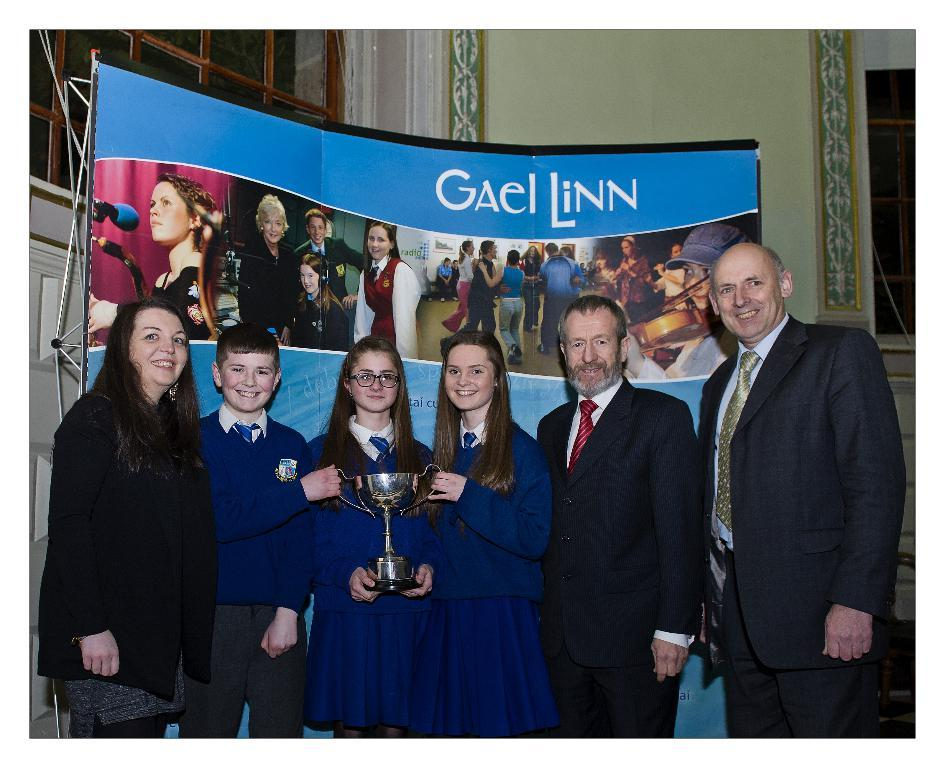What is happening in the image? There are people standing in the image, some of whom are students. What are the students holding in the image? The students are holding a trophy. What can be seen in the background of the image? There is a window and a wall in the background of the image. Is there any text or signage visible in the image? Yes, there is a banner in the image. What type of bun is being served to the monkey in the image? There is no monkey or bun present in the image. 